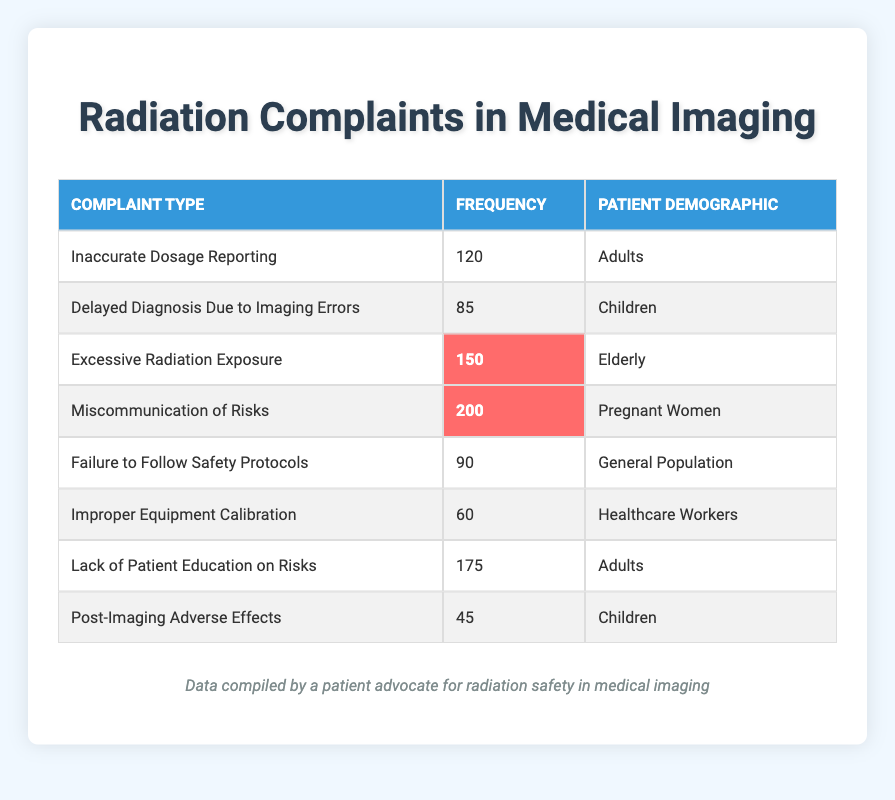What is the frequency of complaints related to excessive radiation exposure among the elderly? The table shows a specific row for "Excessive Radiation Exposure" listed under the demographic "Elderly" with a frequency of 150. Therefore, the answer can be directly found in the table.
Answer: 150 Which complaint has the highest frequency overall? By reviewing the frequencies listed in the table, "Miscommunication of Risks" has the highest frequency of 200. I compared all the frequencies across the different complaint types to reach this conclusion.
Answer: 200 How many total complaints were reported for the adult demographic? To find the total for adults, I will sum the frequencies for "Inaccurate Dosage Reporting" (120) and "Lack of Patient Education on Risks" (175). Adding these gives 120 + 175 = 295, thus the total complaints can be derived.
Answer: 295 Is the frequency of complaints related to post-imaging adverse effects higher among children than the frequency of miscommunication of risks among pregnant women? The frequency for "Post-Imaging Adverse Effects" among children is 45, while for "Miscommunication of Risks" among pregnant women, it is 200. Since 45 is less than 200, the statement is false. The factual comparison shows the frequencies clearly in the table.
Answer: No What is the average frequency of all complaints listed for the general population? The only complaint listed for the general population is "Failure to Follow Safety Protocols" with a frequency of 90. The average of one number is simply that number itself, leading to the conclusion that the average is 90.
Answer: 90 How many more complaints about lack of patient education on risks were reported compared to delayed diagnosis due to imaging errors? The "Lack of Patient Education on Risks" has a frequency of 175 and "Delayed Diagnosis Due to Imaging Errors" has a frequency of 85. To find how many more, subtract 85 from 175, resulting in 175 - 85 = 90. The mathematical operation is straightforward and leads directly to the answer.
Answer: 90 Are there more complaints from children regarding delayed diagnosis due to imaging errors than from elderly about excessive radiation exposure? The frequency for children related to "Delayed Diagnosis Due to Imaging Errors" is 85, and for elderly regarding "Excessive Radiation Exposure," it is 150. Since 85 is less than 150, the answer to this inquiry is negative, indicating that there are fewer complaints from children in this context.
Answer: No What is the total frequency of all complaints reported in the table? To calculate the total frequency, we sum all the individual frequencies listed in the table: 120 + 85 + 150 + 200 + 90 + 60 + 175 + 45 = 1025. This involves adding each value together systematically for accuracy.
Answer: 1025 